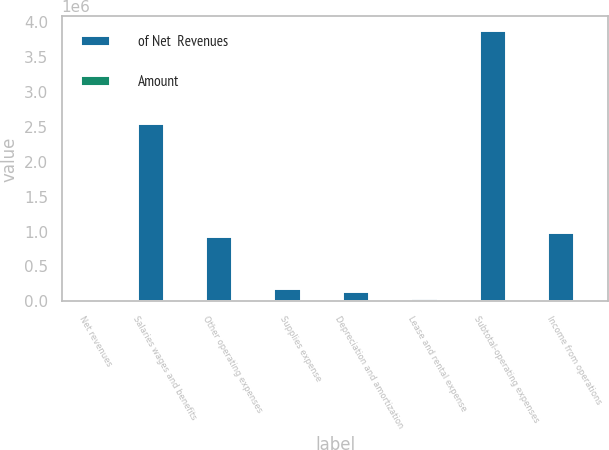<chart> <loc_0><loc_0><loc_500><loc_500><stacked_bar_chart><ecel><fcel>Net revenues<fcel>Salaries wages and benefits<fcel>Other operating expenses<fcel>Supplies expense<fcel>Depreciation and amortization<fcel>Lease and rental expense<fcel>Subtotal-operating expenses<fcel>Income from operations<nl><fcel>of Net  Revenues<fcel>100<fcel>2.5583e+06<fcel>935562<fcel>197305<fcel>153924<fcel>46942<fcel>3.89203e+06<fcel>999149<nl><fcel>Amount<fcel>100<fcel>52.3<fcel>19.1<fcel>4<fcel>3.1<fcel>1<fcel>79.6<fcel>20.4<nl></chart> 